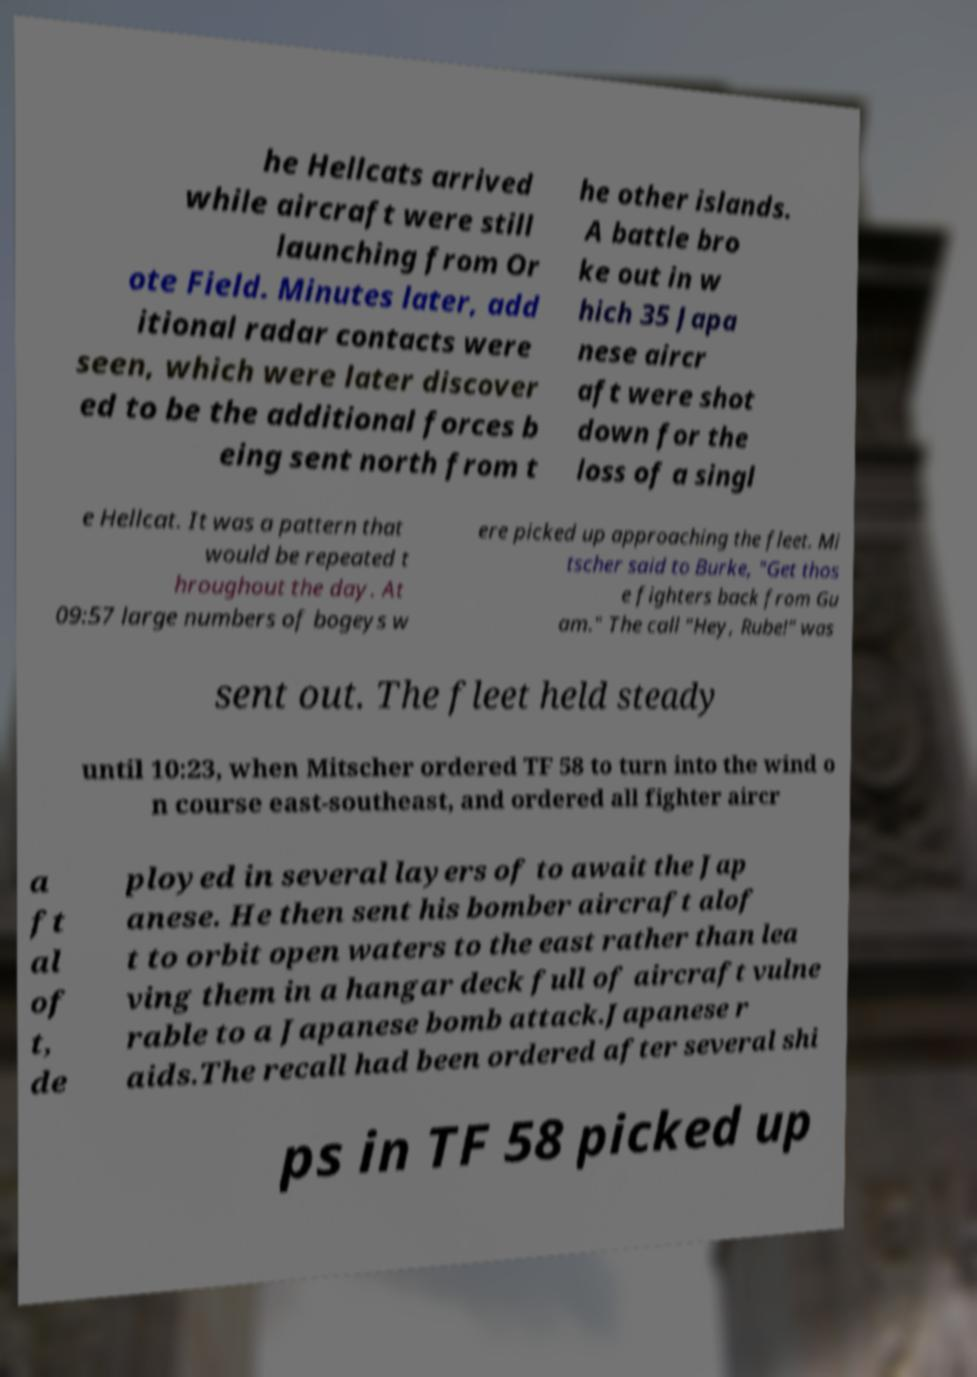Please read and relay the text visible in this image. What does it say? he Hellcats arrived while aircraft were still launching from Or ote Field. Minutes later, add itional radar contacts were seen, which were later discover ed to be the additional forces b eing sent north from t he other islands. A battle bro ke out in w hich 35 Japa nese aircr aft were shot down for the loss of a singl e Hellcat. It was a pattern that would be repeated t hroughout the day. At 09:57 large numbers of bogeys w ere picked up approaching the fleet. Mi tscher said to Burke, "Get thos e fighters back from Gu am." The call "Hey, Rube!" was sent out. The fleet held steady until 10:23, when Mitscher ordered TF 58 to turn into the wind o n course east-southeast, and ordered all fighter aircr a ft al of t, de ployed in several layers of to await the Jap anese. He then sent his bomber aircraft alof t to orbit open waters to the east rather than lea ving them in a hangar deck full of aircraft vulne rable to a Japanese bomb attack.Japanese r aids.The recall had been ordered after several shi ps in TF 58 picked up 